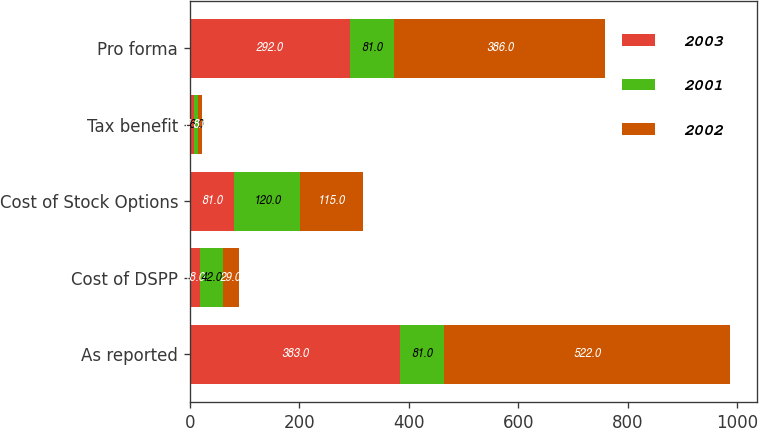<chart> <loc_0><loc_0><loc_500><loc_500><stacked_bar_chart><ecel><fcel>As reported<fcel>Cost of DSPP<fcel>Cost of Stock Options<fcel>Tax benefit<fcel>Pro forma<nl><fcel>2003<fcel>383<fcel>18<fcel>81<fcel>8<fcel>292<nl><fcel>2001<fcel>81<fcel>42<fcel>120<fcel>6<fcel>81<nl><fcel>2002<fcel>522<fcel>29<fcel>115<fcel>8<fcel>386<nl></chart> 